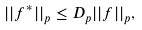<formula> <loc_0><loc_0><loc_500><loc_500>| | f ^ { * } | | _ { p } \leq D _ { p } | | f | | _ { p } ,</formula> 